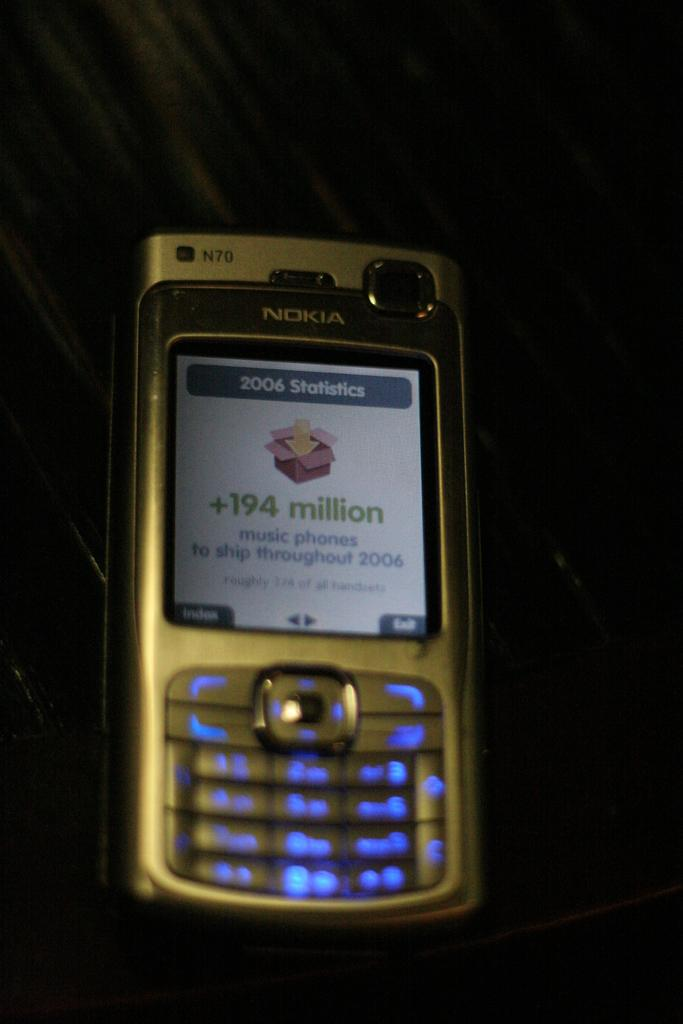<image>
Provide a brief description of the given image. a old nokia phone with 194 million on the screen. 